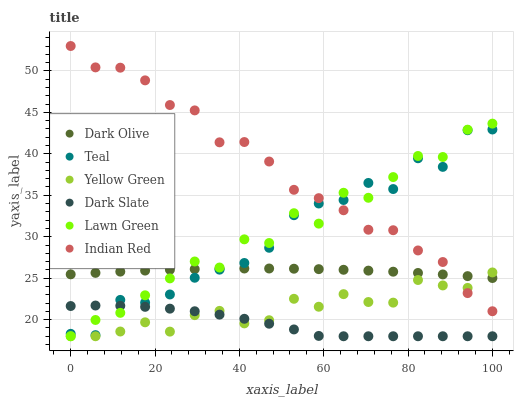Does Dark Slate have the minimum area under the curve?
Answer yes or no. Yes. Does Indian Red have the maximum area under the curve?
Answer yes or no. Yes. Does Lawn Green have the minimum area under the curve?
Answer yes or no. No. Does Lawn Green have the maximum area under the curve?
Answer yes or no. No. Is Dark Olive the smoothest?
Answer yes or no. Yes. Is Lawn Green the roughest?
Answer yes or no. Yes. Is Yellow Green the smoothest?
Answer yes or no. No. Is Yellow Green the roughest?
Answer yes or no. No. Does Lawn Green have the lowest value?
Answer yes or no. Yes. Does Dark Olive have the lowest value?
Answer yes or no. No. Does Indian Red have the highest value?
Answer yes or no. Yes. Does Lawn Green have the highest value?
Answer yes or no. No. Is Dark Slate less than Dark Olive?
Answer yes or no. Yes. Is Dark Olive greater than Dark Slate?
Answer yes or no. Yes. Does Indian Red intersect Lawn Green?
Answer yes or no. Yes. Is Indian Red less than Lawn Green?
Answer yes or no. No. Is Indian Red greater than Lawn Green?
Answer yes or no. No. Does Dark Slate intersect Dark Olive?
Answer yes or no. No. 